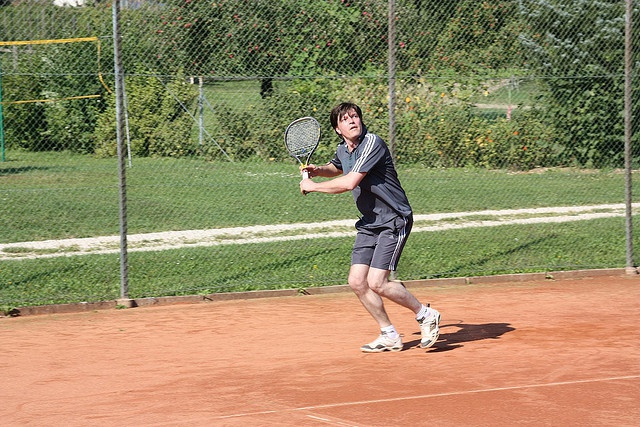Describe the objects in this image and their specific colors. I can see people in black, lightgray, gray, and tan tones and tennis racket in black, darkgray, lightgray, and gray tones in this image. 